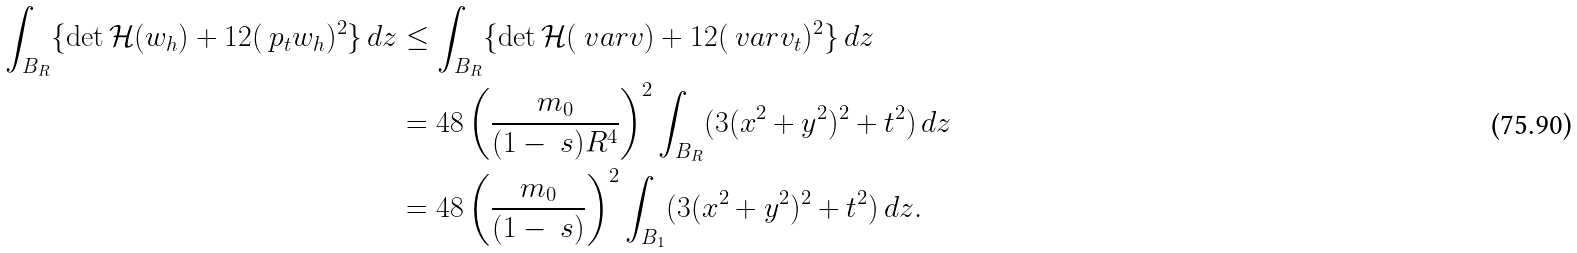<formula> <loc_0><loc_0><loc_500><loc_500>\int _ { B _ { R } } \{ \det \mathcal { H } ( w _ { h } ) + 1 2 ( \ p _ { t } w _ { h } ) ^ { 2 } \} \, d z & \leq \int _ { B _ { R } } \{ \det \mathcal { H } ( \ v a r v ) + 1 2 ( \ v a r v _ { t } ) ^ { 2 } \} \, d z \\ & = 4 8 \left ( \frac { m _ { 0 } } { ( 1 - \ s ) R ^ { 4 } } \right ) ^ { 2 } \int _ { B _ { R } } ( 3 ( x ^ { 2 } + y ^ { 2 } ) ^ { 2 } + t ^ { 2 } ) \, d z \\ & = 4 8 \left ( \frac { m _ { 0 } } { ( 1 - \ s ) } \right ) ^ { 2 } \int _ { B _ { 1 } } ( 3 ( x ^ { 2 } + y ^ { 2 } ) ^ { 2 } + t ^ { 2 } ) \, d z . \\</formula> 